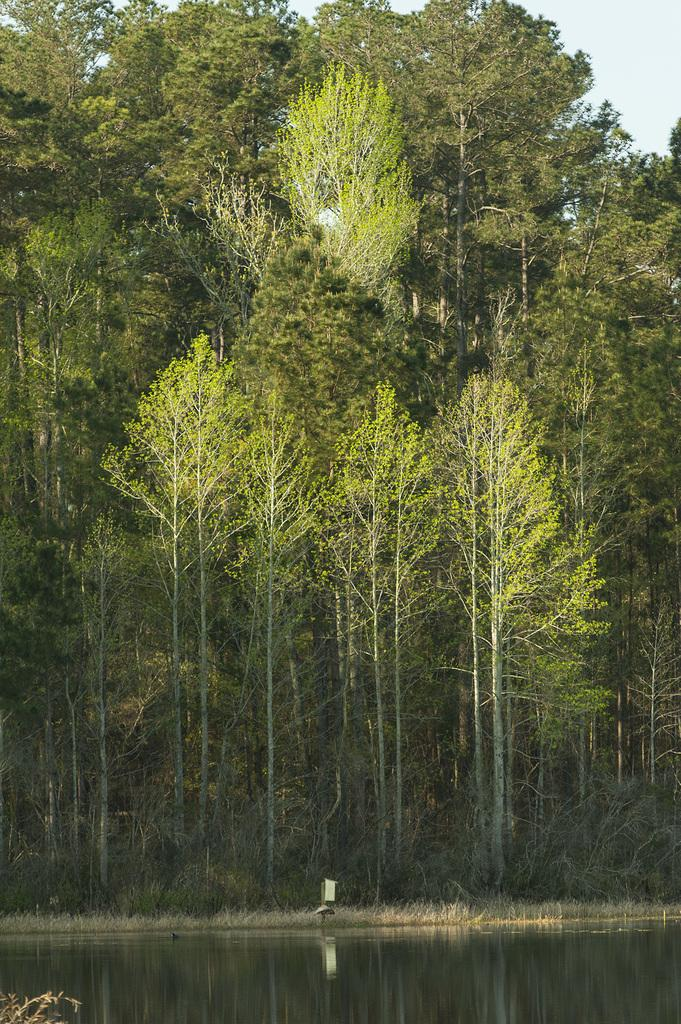What type of vegetation can be seen in the image? There are trees in the image. What is the condition of the grass in the image? Dry grass is visible in the image. What is the presence of water in the image? There is water in the image. What colors can be seen in the sky in the image? The sky is blue and white in color. How many eggs are present in the image? There are no eggs visible in the image. What time of day is it in the image, as indicated by the hour? The provided facts do not mention any specific time of day or hour, and there is no clock or other time-related object in the image. 